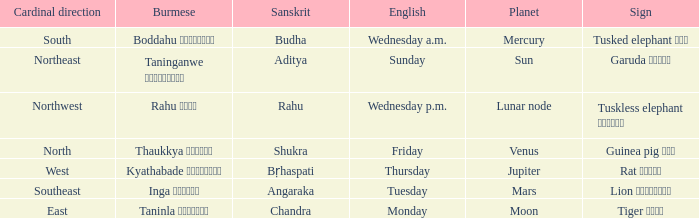What is the cardinal direction associated with Venus? North. 